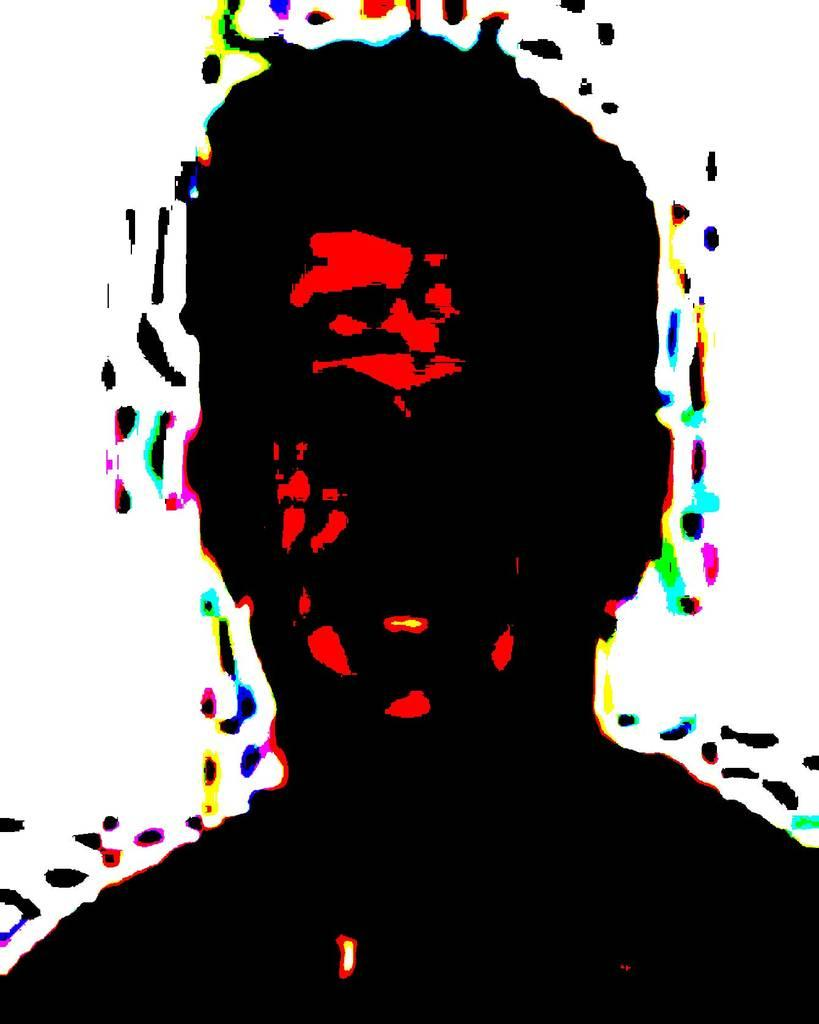What is depicted in the image? There is an illustration of a person in the image. How are the colors used in the illustration? Different colors are used in the illustration. How does the person in the image provide comfort to the drain? There is no drain present in the image, and the person in the illustration is not interacting with any object or situation that would require providing comfort. 